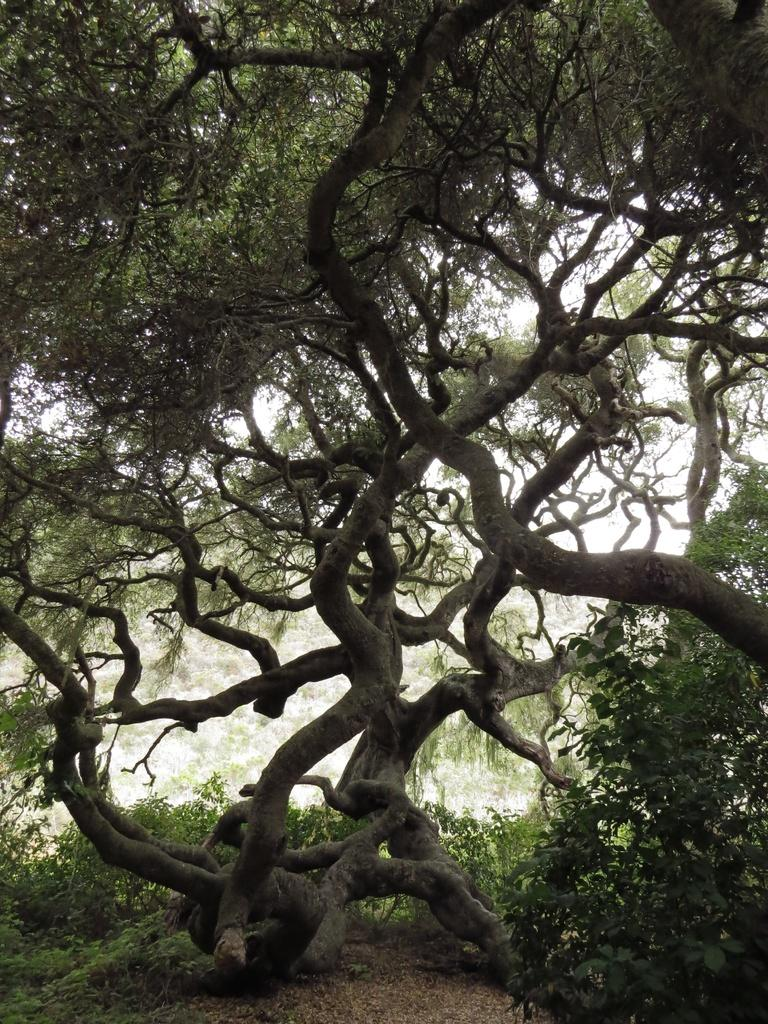What type of vegetation is present in the image? There is a tree in the image. How is the tree positioned in relation to other elements in the image? The tree is in front of other elements in the image. What type of surface is visible at the bottom of the image? There is grass on the surface at the bottom of the image. How is the tree being used to measure the distance to the moon in the image? The tree is not being used to measure the distance to the moon in the image; it is simply a tree in front of other elements. 